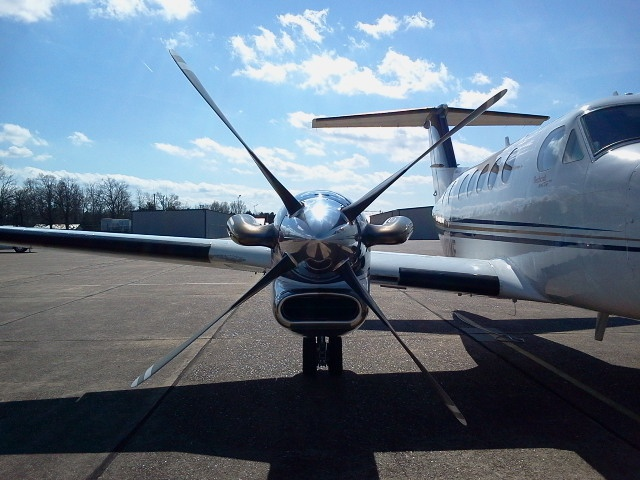Describe the objects in this image and their specific colors. I can see a airplane in lightblue, black, gray, darkgray, and navy tones in this image. 